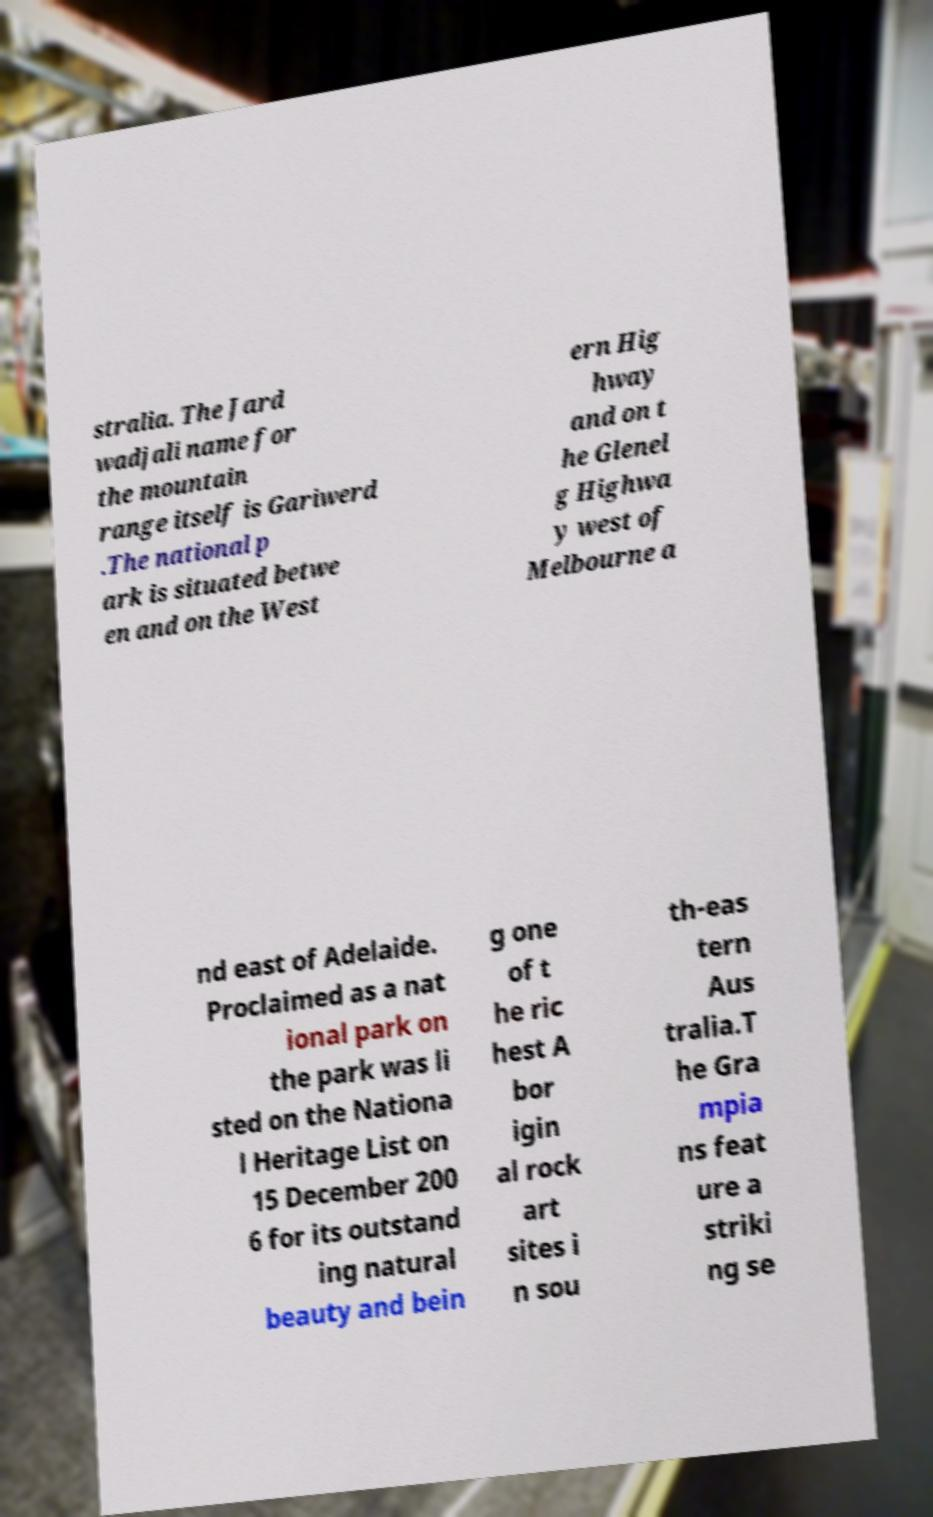For documentation purposes, I need the text within this image transcribed. Could you provide that? stralia. The Jard wadjali name for the mountain range itself is Gariwerd .The national p ark is situated betwe en and on the West ern Hig hway and on t he Glenel g Highwa y west of Melbourne a nd east of Adelaide. Proclaimed as a nat ional park on the park was li sted on the Nationa l Heritage List on 15 December 200 6 for its outstand ing natural beauty and bein g one of t he ric hest A bor igin al rock art sites i n sou th-eas tern Aus tralia.T he Gra mpia ns feat ure a striki ng se 